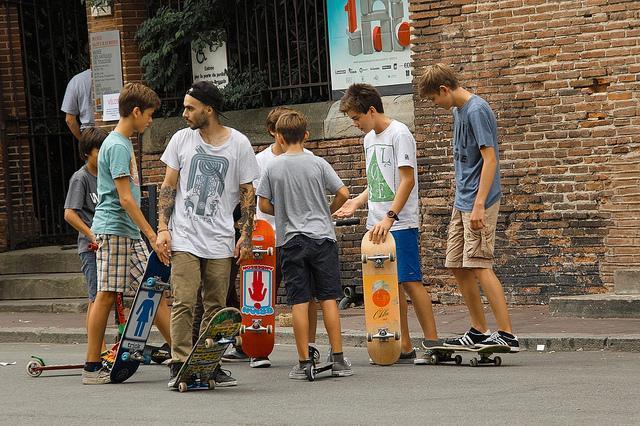How many skateboards are in the photo?
Give a very brief answer. 4. How many people can you see?
Give a very brief answer. 6. How many hot dogs are in this picture?
Give a very brief answer. 0. 